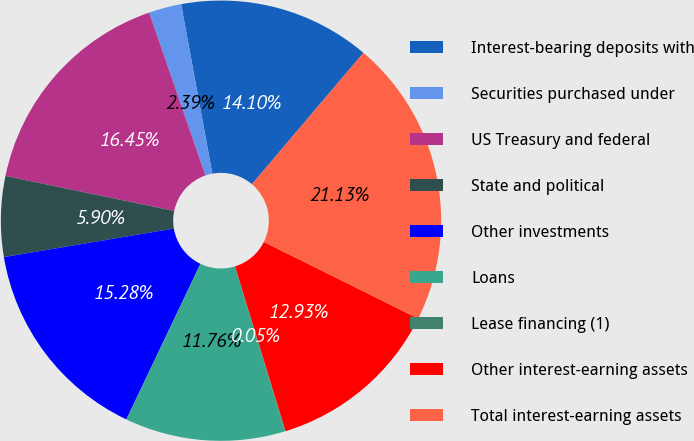<chart> <loc_0><loc_0><loc_500><loc_500><pie_chart><fcel>Interest-bearing deposits with<fcel>Securities purchased under<fcel>US Treasury and federal<fcel>State and political<fcel>Other investments<fcel>Loans<fcel>Lease financing (1)<fcel>Other interest-earning assets<fcel>Total interest-earning assets<nl><fcel>14.1%<fcel>2.39%<fcel>16.45%<fcel>5.9%<fcel>15.28%<fcel>11.76%<fcel>0.05%<fcel>12.93%<fcel>21.13%<nl></chart> 